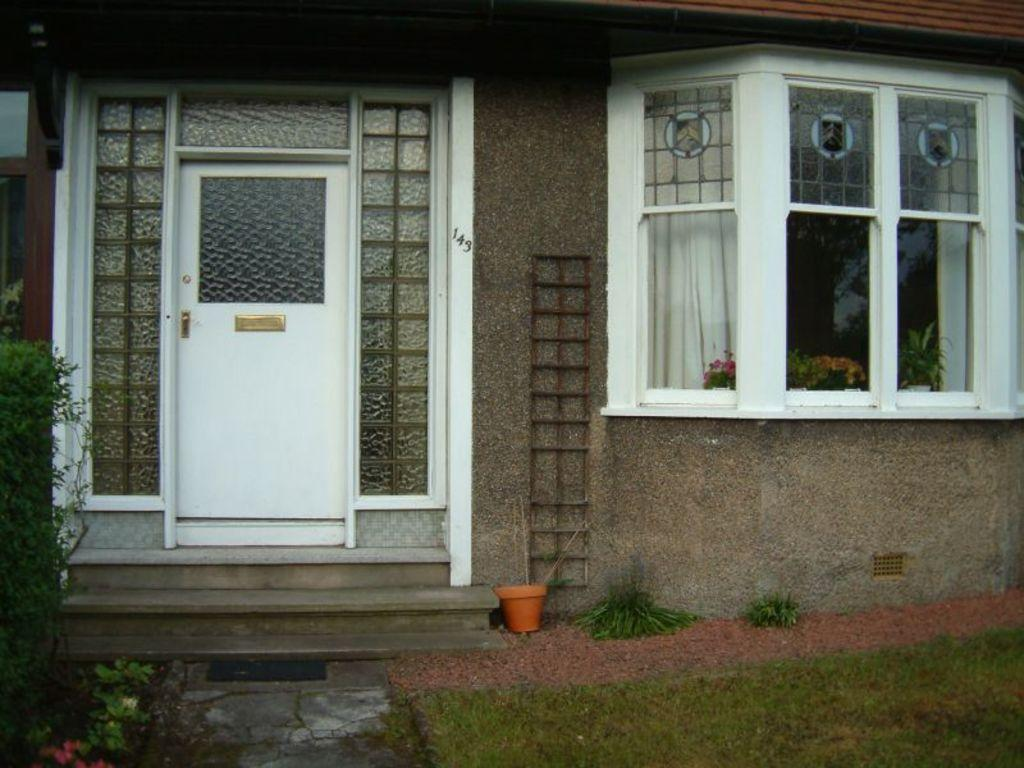What type of structure is visible in the image? There is a house in the image. What can be seen on the house in the image? There is a window, a door, and stairs visible on the house in the image. What is inside the house in the image? There is a pot and a plant visible inside the house in the image. What is outside the house in the image? There is grass visible outside the house in the image. What type of window treatment is present in the image? There are curtains visible in the image. What type of songs can be heard coming from the fan in the image? There is no fan present in the image, and therefore no songs can be heard. 